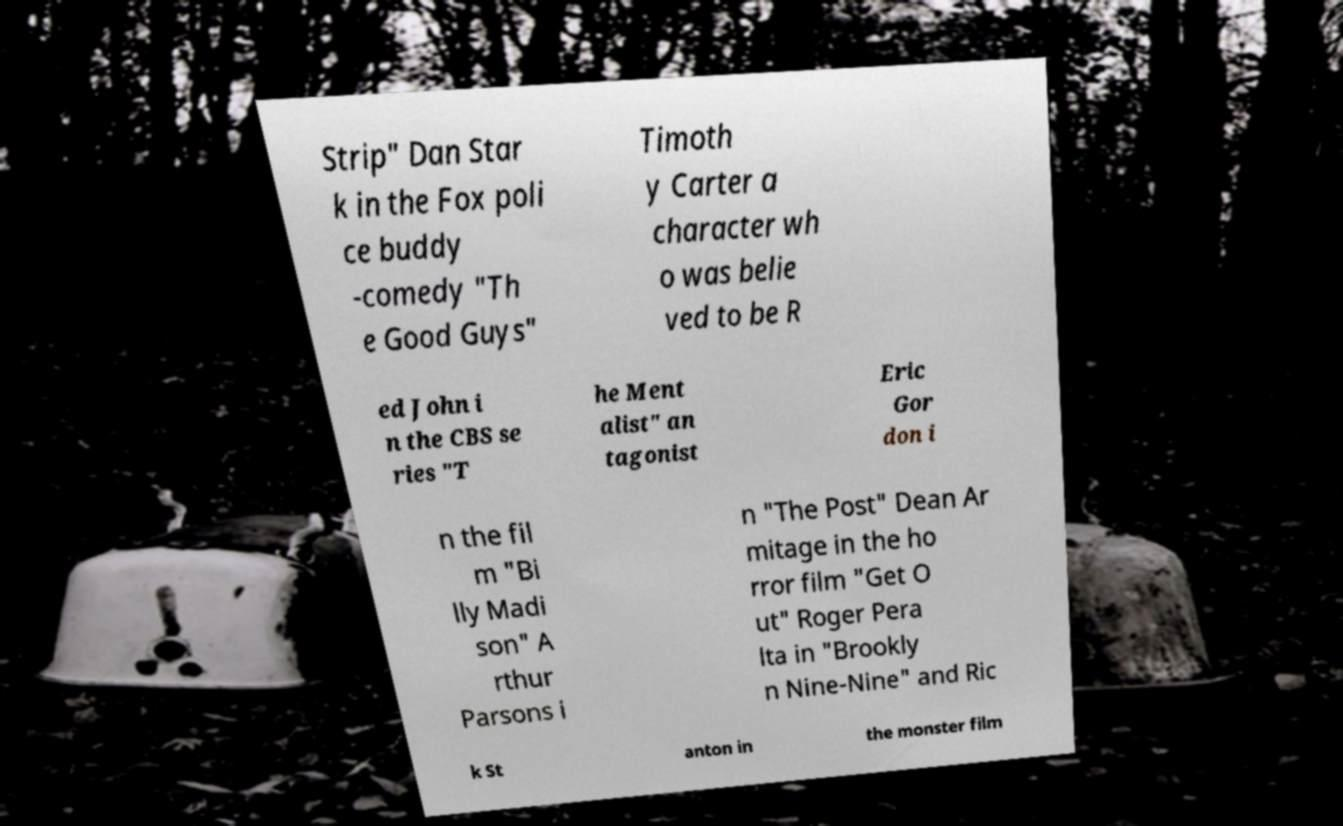Could you assist in decoding the text presented in this image and type it out clearly? Strip" Dan Star k in the Fox poli ce buddy -comedy "Th e Good Guys" Timoth y Carter a character wh o was belie ved to be R ed John i n the CBS se ries "T he Ment alist" an tagonist Eric Gor don i n the fil m "Bi lly Madi son" A rthur Parsons i n "The Post" Dean Ar mitage in the ho rror film "Get O ut" Roger Pera lta in "Brookly n Nine-Nine" and Ric k St anton in the monster film 